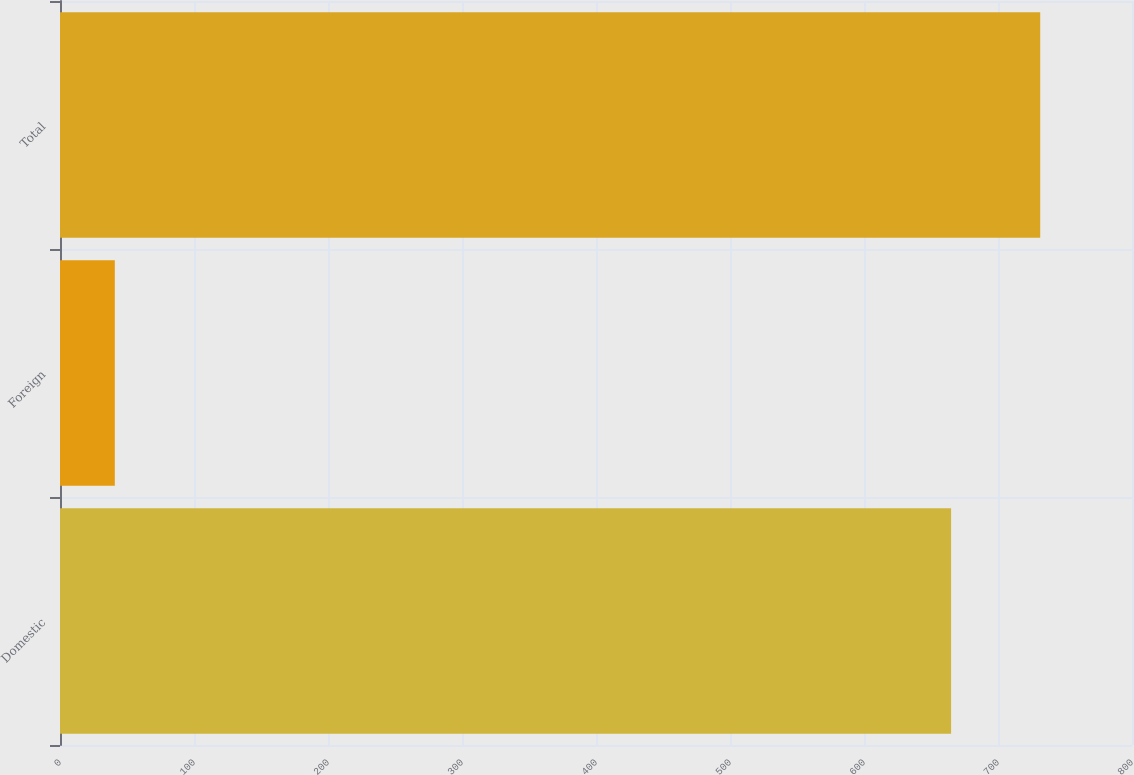Convert chart to OTSL. <chart><loc_0><loc_0><loc_500><loc_500><bar_chart><fcel>Domestic<fcel>Foreign<fcel>Total<nl><fcel>665<fcel>40.9<fcel>731.5<nl></chart> 